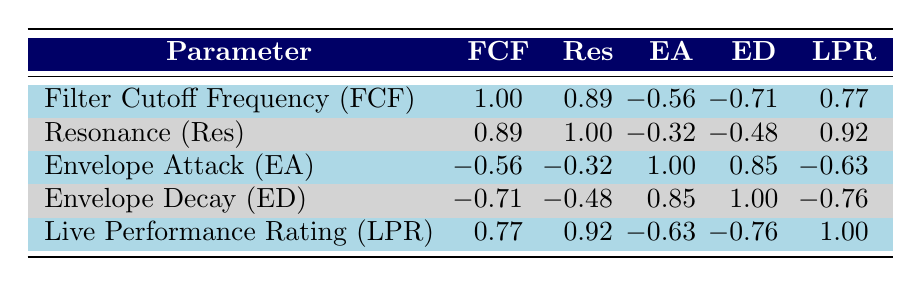What is the filter cutoff frequency (FCF) for the "Sunset Dream" patch? By locating the row corresponding to "Sunset Dream" in the table, we see that the FCF value listed is 8000.
Answer: 8000 What is the resonance value for the "Synthwave Pulse"? The resonance for "Synthwave Pulse" is found by checking the corresponding row in the table, which shows a value of 0.7.
Answer: 0.7 Is the live performance rating (LPR) of "Galactic Drone" greater than 5? The LPR for "Galactic Drone" is 5 as per the table; therefore, it is not greater than 5.
Answer: No What is the average envelope decay (ED) across all patches? The envelope decay values are 0.3, 0.2, 0.5, 0.4, 0.1, and 1.0. Adding these values gives 2.5. To find the average, divide by the number of patches (6): 2.5 / 6 = approximately 0.42.
Answer: 0.42 Which two parameters have the strongest correlation with the live performance rating (LPR)? The highest correlations with LPR are with resonance (0.92) and filter cutoff frequency (0.77). Therefore, the two parameters with the strongest correlations are resonance and filter cutoff frequency.
Answer: Resonance and Filter Cutoff Frequency What is the highest envelope attack (EA) value among all patches? By reviewing the EA values of 0.8, 0.1, 0.4, 0.6, 0.2, and 2.0, we see that 2.0 is the highest value.
Answer: 2.0 Does "Deep Space" have a higher envelope decay (ED) than "Vintage Pad"? The envelope decay for "Deep Space" is 0.2, while for "Vintage Pad" it is 0.4. Since 0.2 is less than 0.4, the statement is false.
Answer: No What is the difference in filter cutoff frequency (FCF) between the "Retro Beat" and "Galactic Drone" patches? The FCF for "Retro Beat" is 3000, and for "Galactic Drone" it is 250. The difference is calculated as 3000 - 250 = 2750.
Answer: 2750 